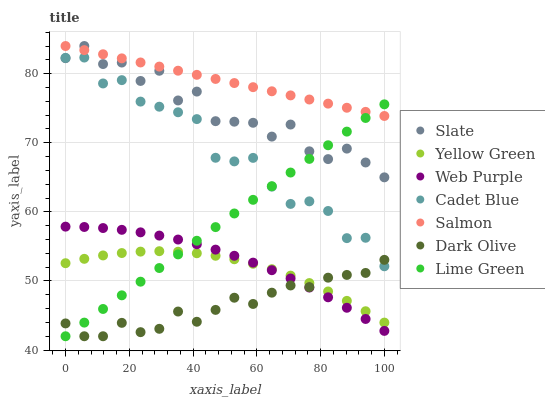Does Dark Olive have the minimum area under the curve?
Answer yes or no. Yes. Does Salmon have the maximum area under the curve?
Answer yes or no. Yes. Does Yellow Green have the minimum area under the curve?
Answer yes or no. No. Does Yellow Green have the maximum area under the curve?
Answer yes or no. No. Is Salmon the smoothest?
Answer yes or no. Yes. Is Slate the roughest?
Answer yes or no. Yes. Is Yellow Green the smoothest?
Answer yes or no. No. Is Yellow Green the roughest?
Answer yes or no. No. Does Dark Olive have the lowest value?
Answer yes or no. Yes. Does Yellow Green have the lowest value?
Answer yes or no. No. Does Salmon have the highest value?
Answer yes or no. Yes. Does Yellow Green have the highest value?
Answer yes or no. No. Is Yellow Green less than Slate?
Answer yes or no. Yes. Is Slate greater than Dark Olive?
Answer yes or no. Yes. Does Slate intersect Lime Green?
Answer yes or no. Yes. Is Slate less than Lime Green?
Answer yes or no. No. Is Slate greater than Lime Green?
Answer yes or no. No. Does Yellow Green intersect Slate?
Answer yes or no. No. 